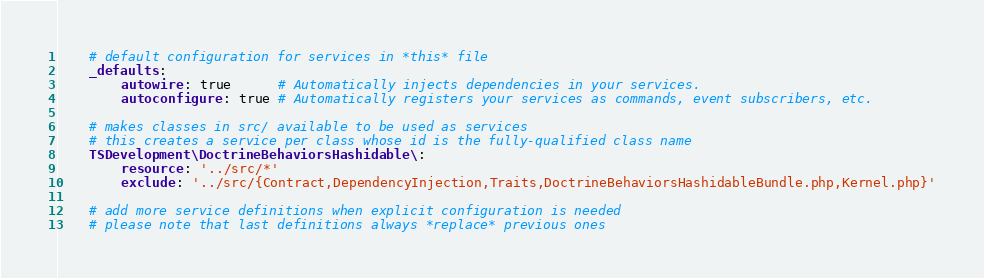Convert code to text. <code><loc_0><loc_0><loc_500><loc_500><_YAML_>    # default configuration for services in *this* file
    _defaults:
        autowire: true      # Automatically injects dependencies in your services.
        autoconfigure: true # Automatically registers your services as commands, event subscribers, etc.

    # makes classes in src/ available to be used as services
    # this creates a service per class whose id is the fully-qualified class name
    TSDevelopment\DoctrineBehaviorsHashidable\:
        resource: '../src/*'
        exclude: '../src/{Contract,DependencyInjection,Traits,DoctrineBehaviorsHashidableBundle.php,Kernel.php}'

    # add more service definitions when explicit configuration is needed
    # please note that last definitions always *replace* previous ones
</code> 